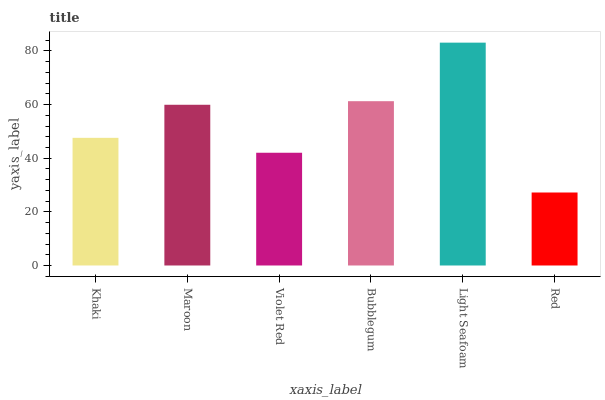Is Red the minimum?
Answer yes or no. Yes. Is Light Seafoam the maximum?
Answer yes or no. Yes. Is Maroon the minimum?
Answer yes or no. No. Is Maroon the maximum?
Answer yes or no. No. Is Maroon greater than Khaki?
Answer yes or no. Yes. Is Khaki less than Maroon?
Answer yes or no. Yes. Is Khaki greater than Maroon?
Answer yes or no. No. Is Maroon less than Khaki?
Answer yes or no. No. Is Maroon the high median?
Answer yes or no. Yes. Is Khaki the low median?
Answer yes or no. Yes. Is Khaki the high median?
Answer yes or no. No. Is Bubblegum the low median?
Answer yes or no. No. 